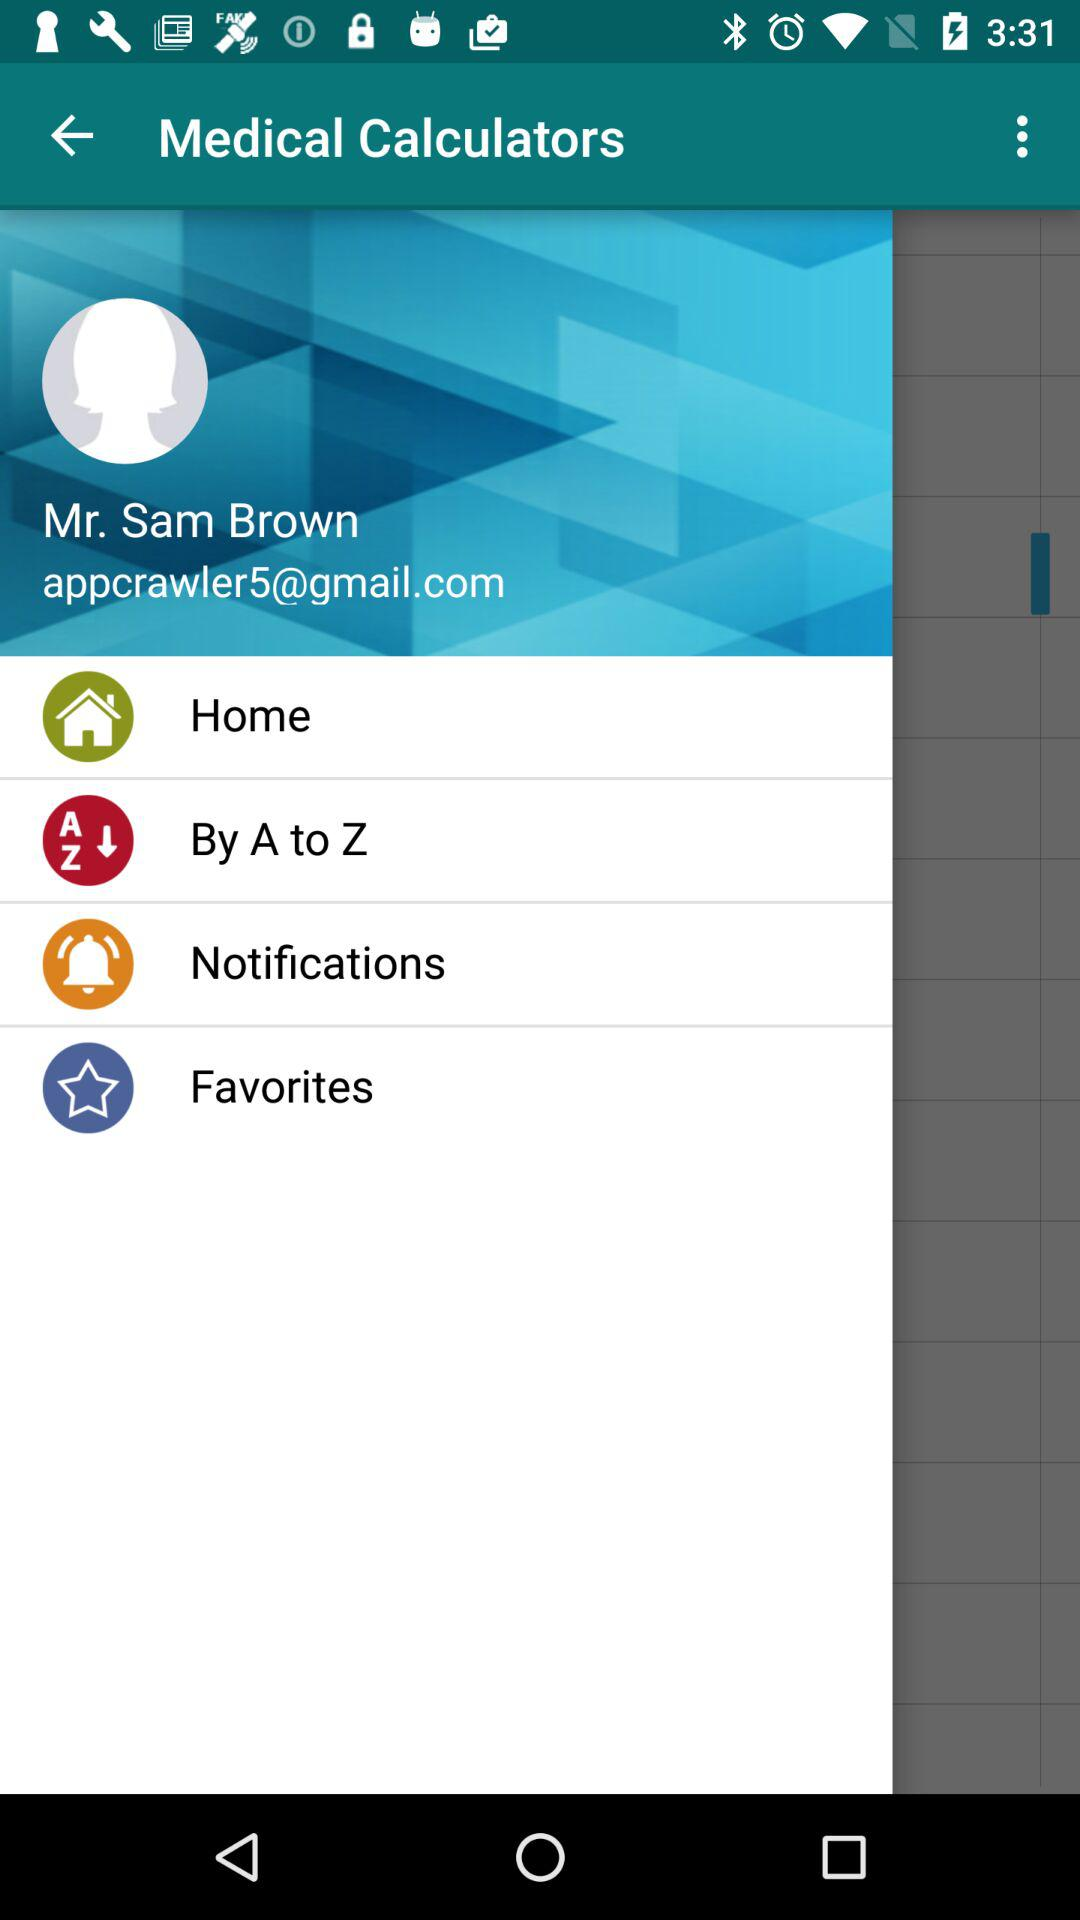What is the user name? The user name is Mr. Sam Brown. 